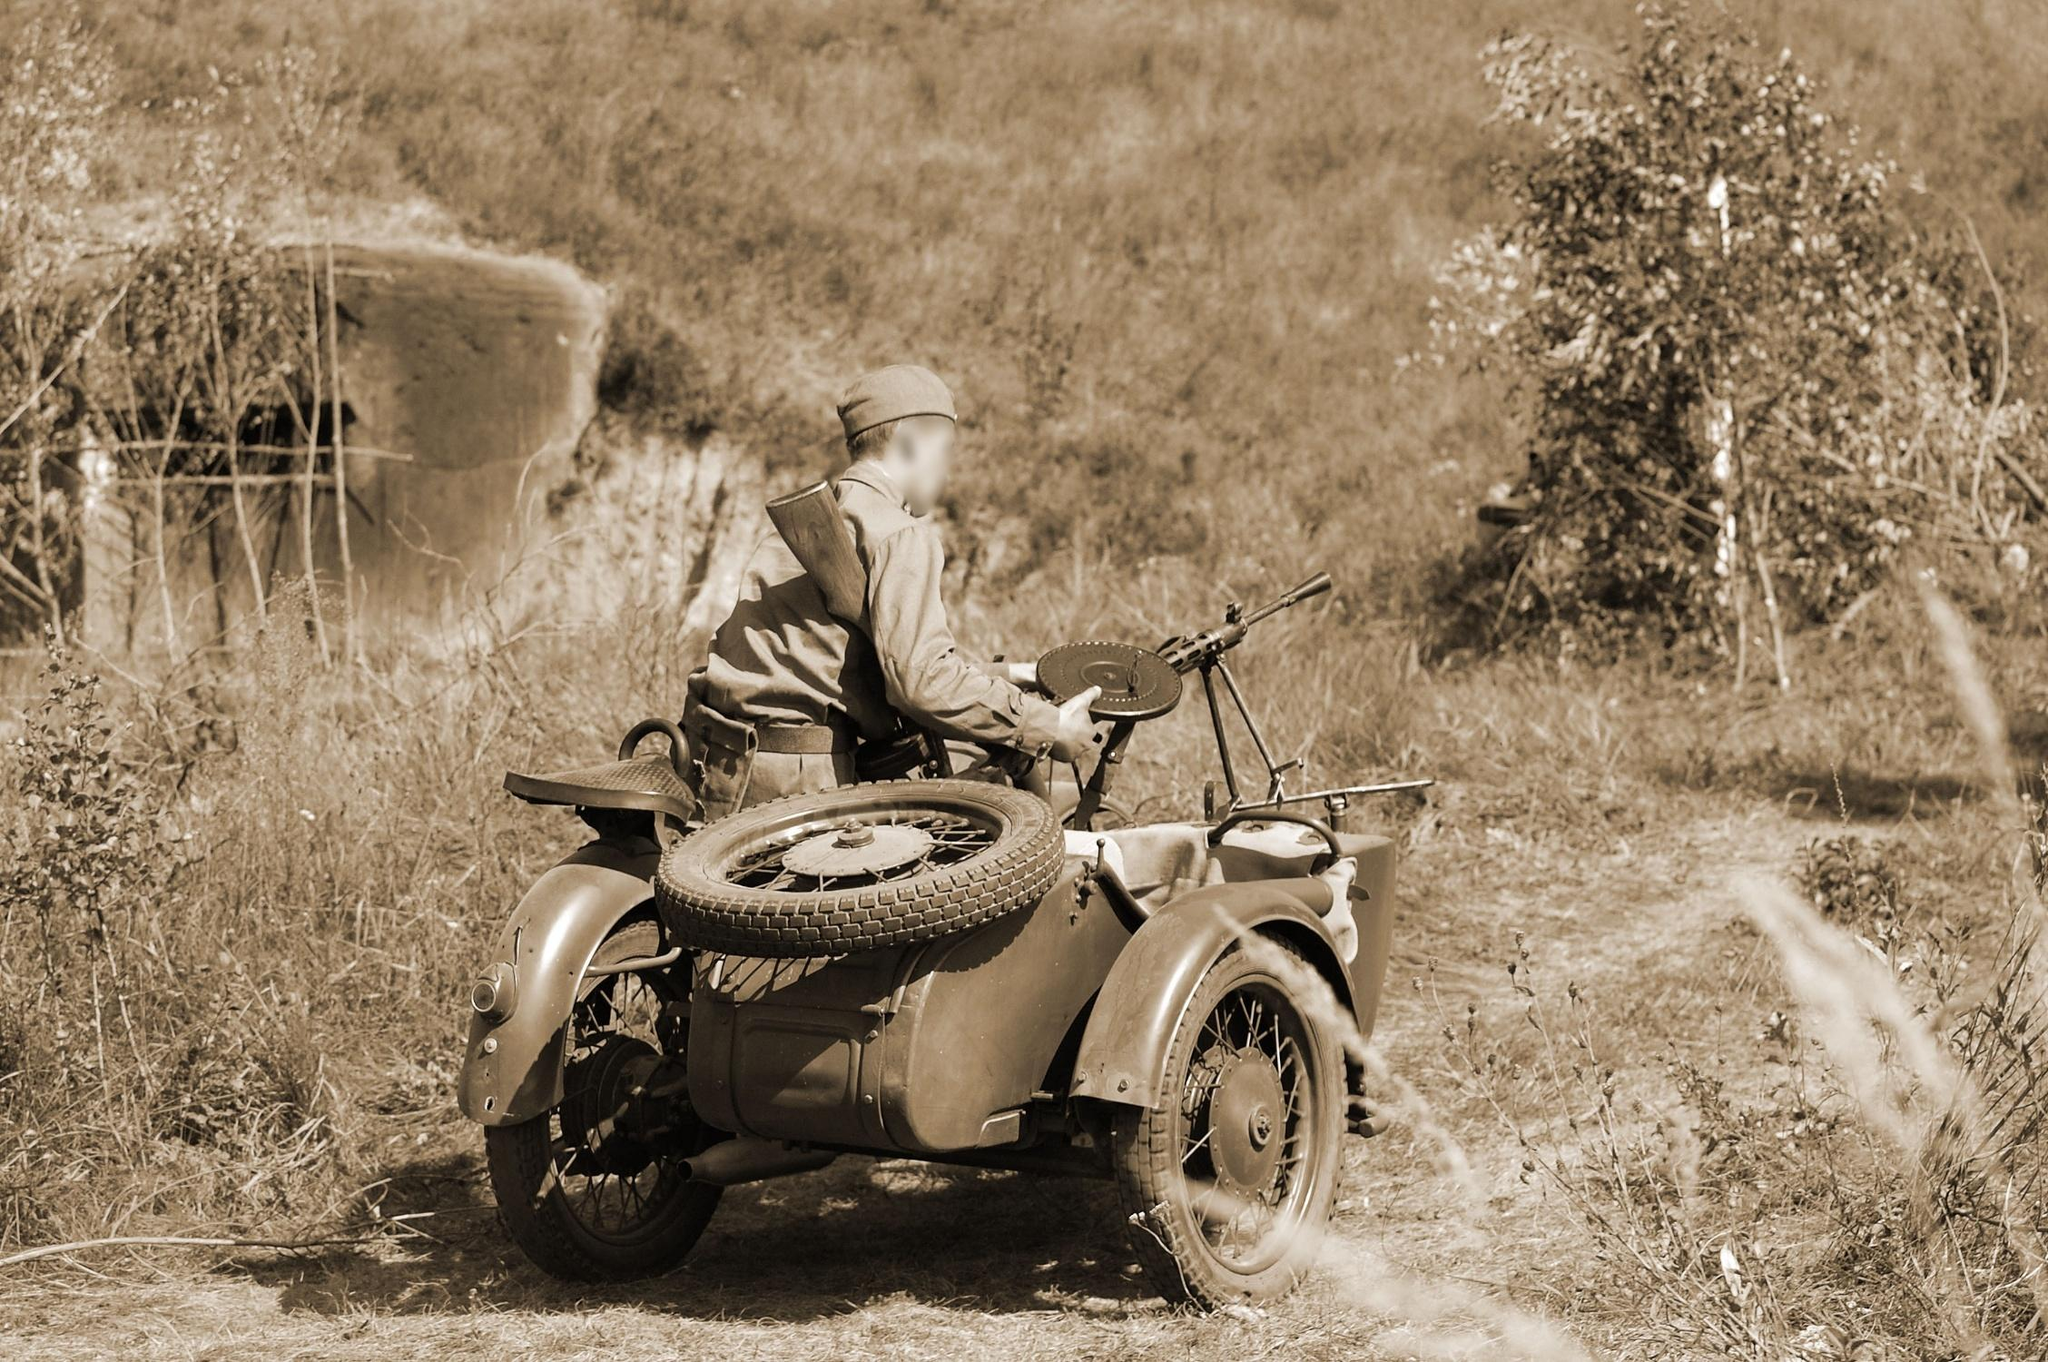What do you think is going on in this snapshot? In the sepia-toned image, a figure clad in military gear and helmet sits astride a vintage motorcycle with a sidecar, suggesting a scenario possibly related to a historical or reenactment scene. The motorcycle, equipped with a spare tire, indicates preparation for a long journey or rough terrain, which aligns with the dirt road it travels on. The secluded rural setting, with lush bushes and a prominent rocky outcrop, adds to the ambiance of solitude and adventure. This snapshot could depict a moment of pause in a journey, as the rider appears to look off to the side, maybe scanning the surroundings or reflecting on the journey ahead. 